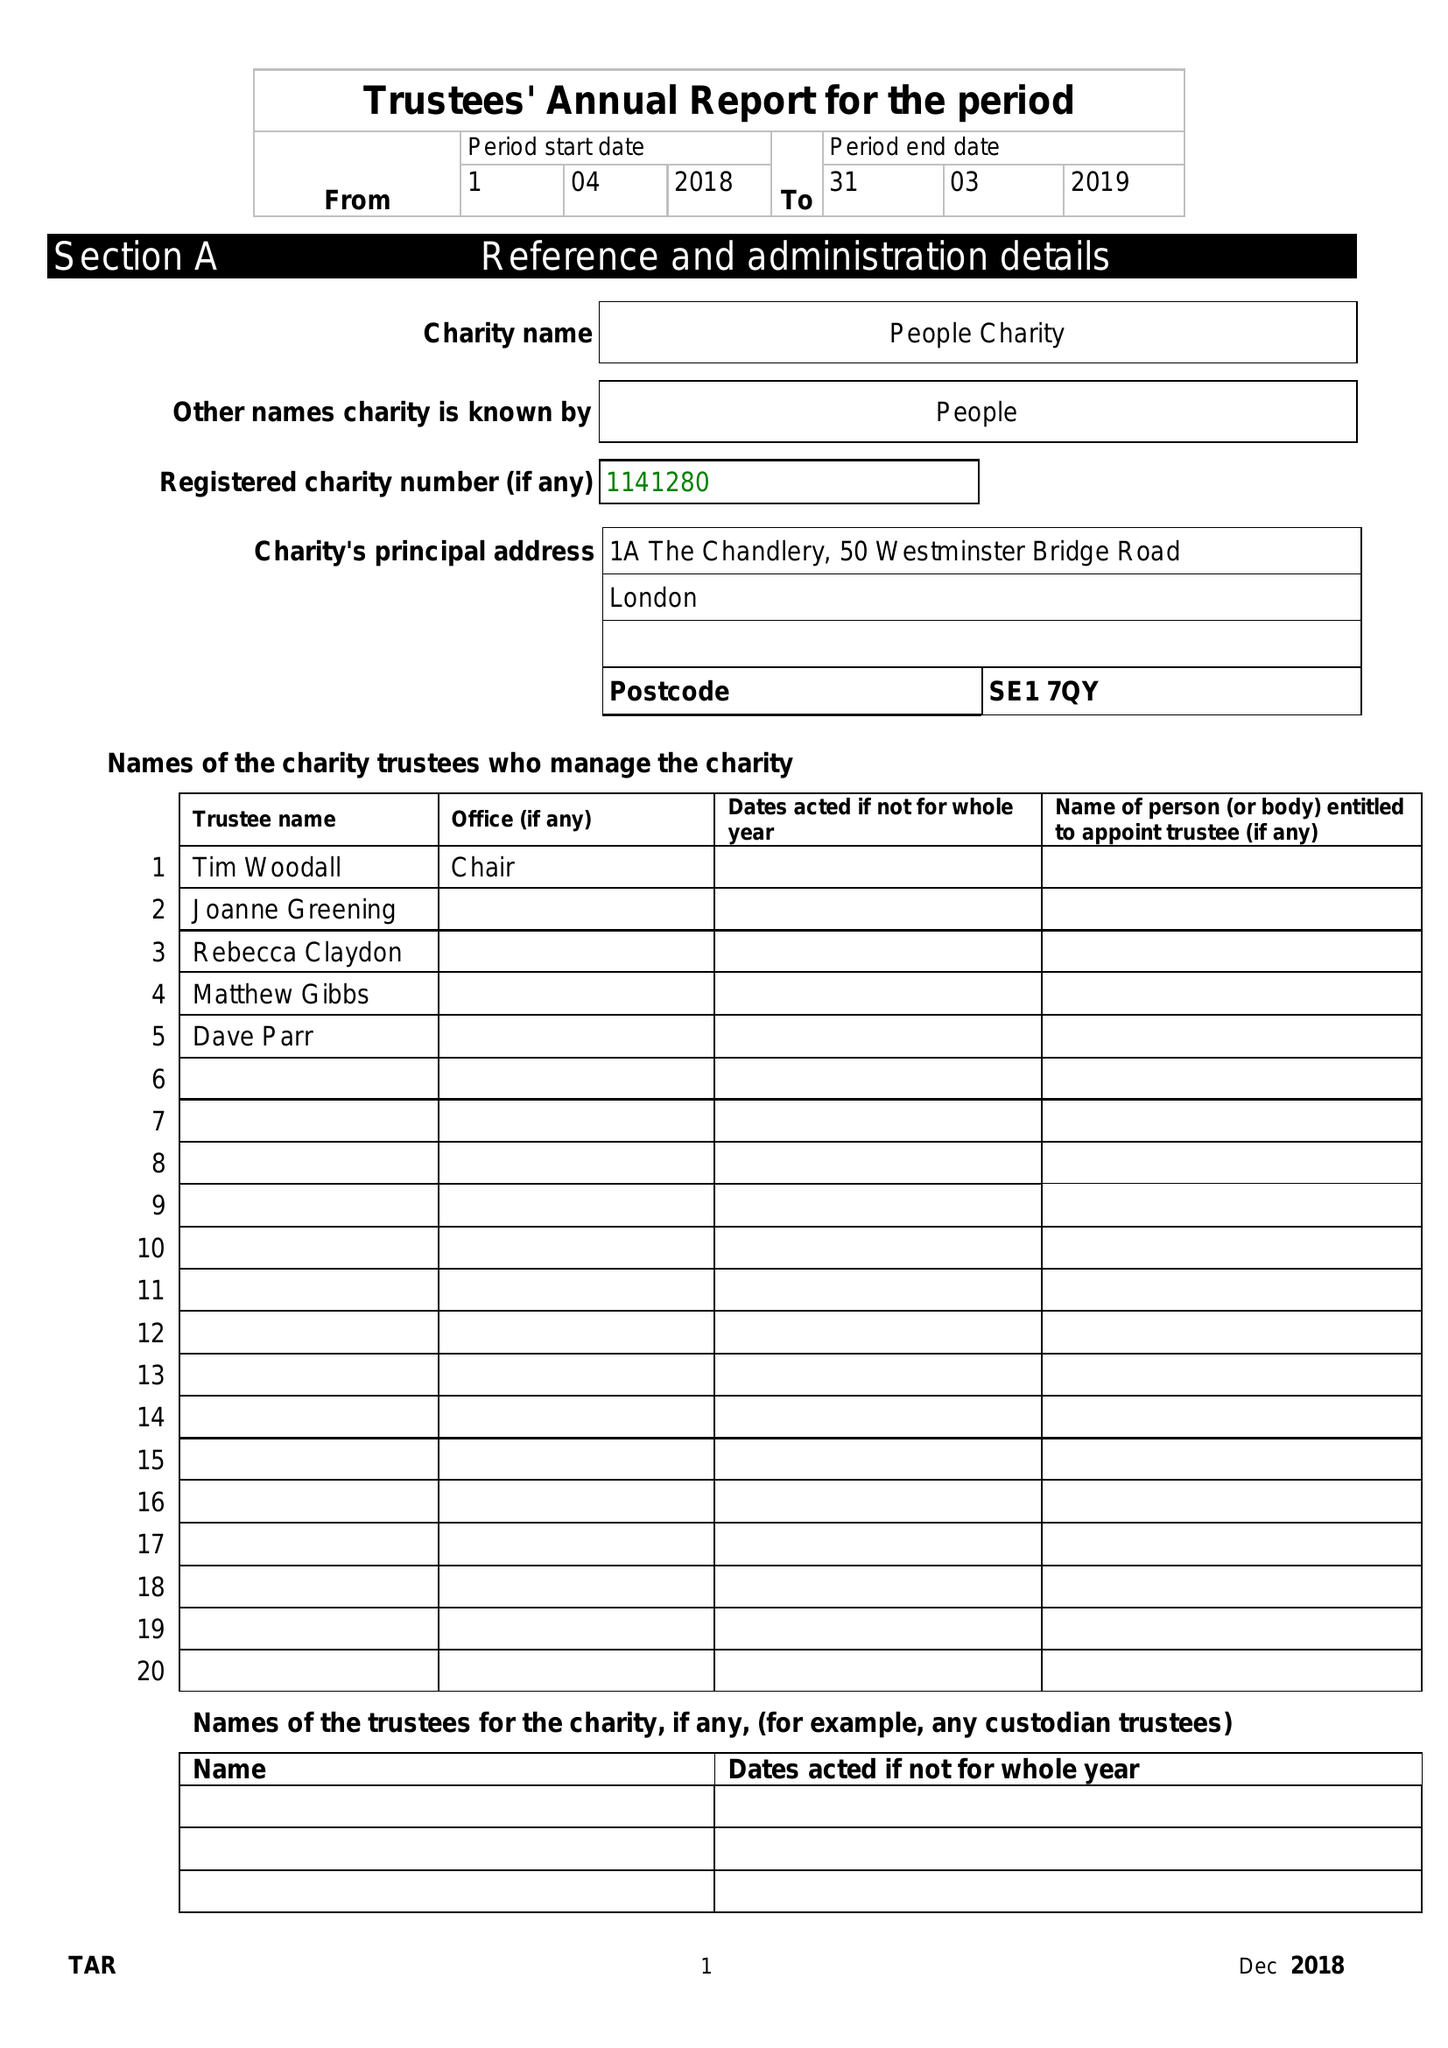What is the value for the income_annually_in_british_pounds?
Answer the question using a single word or phrase. 54971.00 